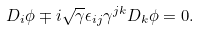Convert formula to latex. <formula><loc_0><loc_0><loc_500><loc_500>D _ { i } \phi \mp i \sqrt { \gamma } \epsilon _ { i j } \gamma ^ { j k } D _ { k } \phi = 0 .</formula> 